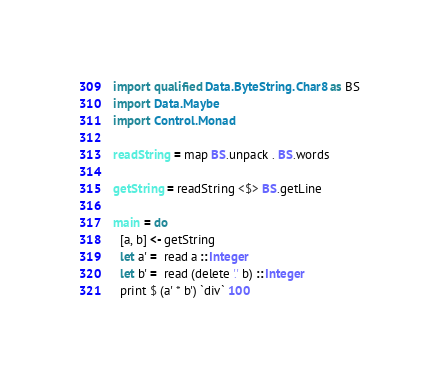<code> <loc_0><loc_0><loc_500><loc_500><_Haskell_>import qualified Data.ByteString.Char8 as BS
import Data.Maybe
import Control.Monad

readString = map BS.unpack . BS.words

getString = readString <$> BS.getLine

main = do
  [a, b] <- getString
  let a' =  read a :: Integer
  let b' =  read (delete '.' b) :: Integer
  print $ (a' * b') `div` 100</code> 